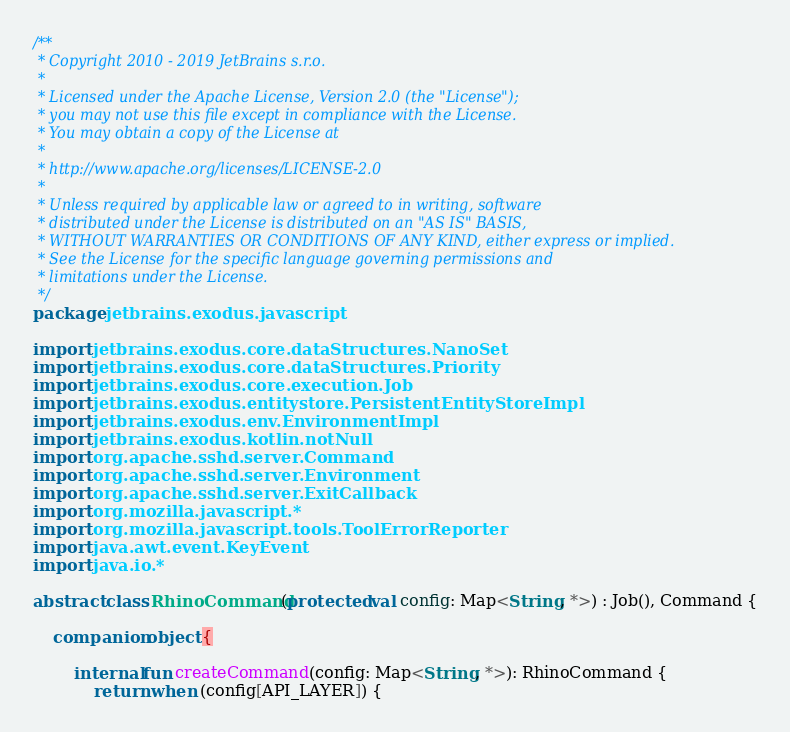Convert code to text. <code><loc_0><loc_0><loc_500><loc_500><_Kotlin_>/**
 * Copyright 2010 - 2019 JetBrains s.r.o.
 *
 * Licensed under the Apache License, Version 2.0 (the "License");
 * you may not use this file except in compliance with the License.
 * You may obtain a copy of the License at
 *
 * http://www.apache.org/licenses/LICENSE-2.0
 *
 * Unless required by applicable law or agreed to in writing, software
 * distributed under the License is distributed on an "AS IS" BASIS,
 * WITHOUT WARRANTIES OR CONDITIONS OF ANY KIND, either express or implied.
 * See the License for the specific language governing permissions and
 * limitations under the License.
 */
package jetbrains.exodus.javascript

import jetbrains.exodus.core.dataStructures.NanoSet
import jetbrains.exodus.core.dataStructures.Priority
import jetbrains.exodus.core.execution.Job
import jetbrains.exodus.entitystore.PersistentEntityStoreImpl
import jetbrains.exodus.env.EnvironmentImpl
import jetbrains.exodus.kotlin.notNull
import org.apache.sshd.server.Command
import org.apache.sshd.server.Environment
import org.apache.sshd.server.ExitCallback
import org.mozilla.javascript.*
import org.mozilla.javascript.tools.ToolErrorReporter
import java.awt.event.KeyEvent
import java.io.*

abstract class RhinoCommand(protected val config: Map<String, *>) : Job(), Command {

    companion object {

        internal fun createCommand(config: Map<String, *>): RhinoCommand {
            return when (config[API_LAYER]) {</code> 